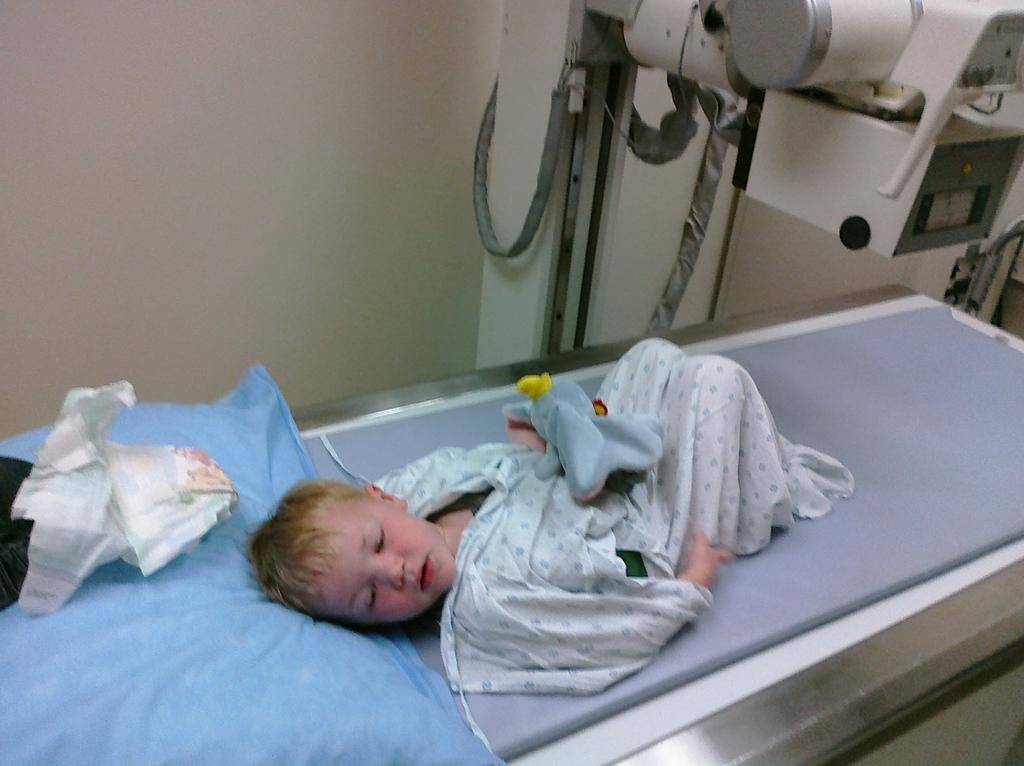What is the main subject of the image? There is a child in the image. Where is the child located? The child is laying on a hospital bed. What is supporting the child's head? There is a pillow under the child's head. What is on the pillow? There is a diaper on the pillow. What else can be seen in the image? There is medical equipment visible in the image. What type of flesh can be seen on the child's face in the image? There is no mention of the child's face or any flesh in the provided facts, so we cannot answer this question. --- Facts: 1. There is a car in the image. 2. The car is parked on the street. 3. There are trees in the background. 4. The sky is visible in the image. 5. The car has a red color. Absurd Topics: parrot, dance, ocean Conversation: What is the main subject of the image? There is a car in the image. Where is the car located? The car is parked on the street. What can be seen in the background of the image? There are trees in the background. What is visible at the top of the image? The sky is visible in the image. What color is the car? The car has a red color. Reasoning: Let's think step by step in order to produce the conversation. We start by identifying the main subject of the image, which is the car. Then, we describe the car's location and the objects that are visible in the background, such as the trees and sky. Finally, we mention the color of the car, which adds detail to the description. Absurd Question/Answer: Can you see a parrot dancing near the ocean in the image? There is no mention of a parrot, dancing, or the ocean in the provided facts, so we cannot answer this question. 